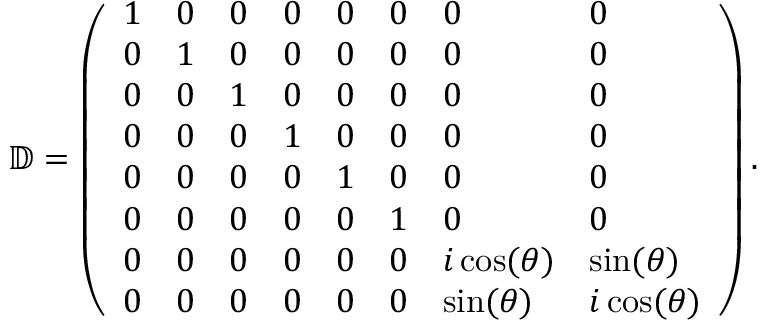<formula> <loc_0><loc_0><loc_500><loc_500>\mathbb { D } = \left ( \begin{array} { l l l l l l l l } { 1 } & { 0 } & { 0 } & { 0 } & { 0 } & { 0 } & { 0 } & { 0 } \\ { 0 } & { 1 } & { 0 } & { 0 } & { 0 } & { 0 } & { 0 } & { 0 } \\ { 0 } & { 0 } & { 1 } & { 0 } & { 0 } & { 0 } & { 0 } & { 0 } \\ { 0 } & { 0 } & { 0 } & { 1 } & { 0 } & { 0 } & { 0 } & { 0 } \\ { 0 } & { 0 } & { 0 } & { 0 } & { 1 } & { 0 } & { 0 } & { 0 } \\ { 0 } & { 0 } & { 0 } & { 0 } & { 0 } & { 1 } & { 0 } & { 0 } \\ { 0 } & { 0 } & { 0 } & { 0 } & { 0 } & { 0 } & { i \cos ( \theta ) } & { \sin ( \theta ) } \\ { 0 } & { 0 } & { 0 } & { 0 } & { 0 } & { 0 } & { \sin ( \theta ) } & { i \cos ( \theta ) } \end{array} \right ) .</formula> 